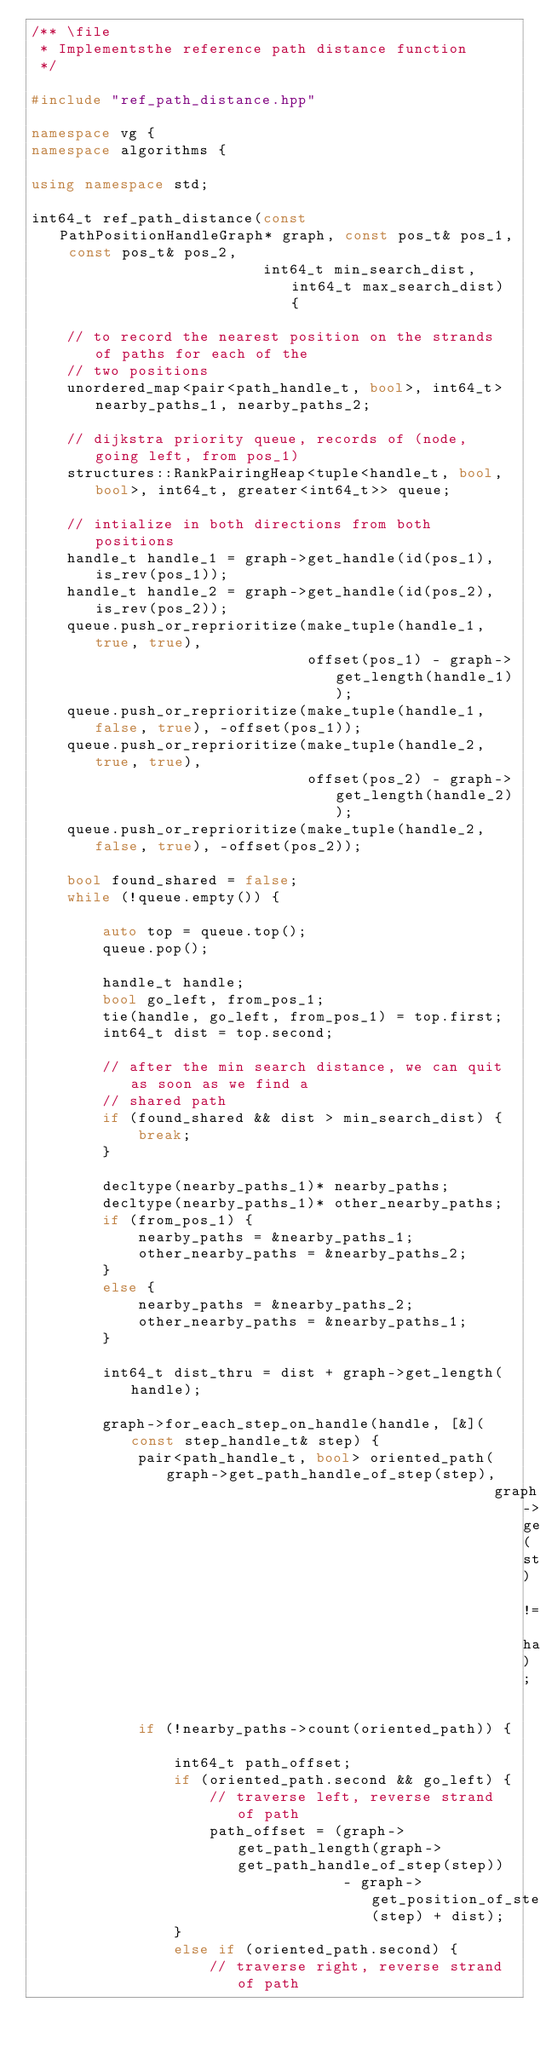Convert code to text. <code><loc_0><loc_0><loc_500><loc_500><_C++_>/** \file
 * Implementsthe reference path distance function
 */

#include "ref_path_distance.hpp"

namespace vg {
namespace algorithms {

using namespace std;

int64_t ref_path_distance(const PathPositionHandleGraph* graph, const pos_t& pos_1, const pos_t& pos_2,
                          int64_t min_search_dist, int64_t max_search_dist) {
    
    // to record the nearest position on the strands of paths for each of the
    // two positions
    unordered_map<pair<path_handle_t, bool>, int64_t> nearby_paths_1, nearby_paths_2;
    
    // dijkstra priority queue, records of (node, going left, from pos_1)
    structures::RankPairingHeap<tuple<handle_t, bool, bool>, int64_t, greater<int64_t>> queue;
    
    // intialize in both directions from both positions
    handle_t handle_1 = graph->get_handle(id(pos_1), is_rev(pos_1));
    handle_t handle_2 = graph->get_handle(id(pos_2), is_rev(pos_2));
    queue.push_or_reprioritize(make_tuple(handle_1, true, true),
                               offset(pos_1) - graph->get_length(handle_1));
    queue.push_or_reprioritize(make_tuple(handle_1, false, true), -offset(pos_1));
    queue.push_or_reprioritize(make_tuple(handle_2, true, true),
                               offset(pos_2) - graph->get_length(handle_2));
    queue.push_or_reprioritize(make_tuple(handle_2, false, true), -offset(pos_2));
    
    bool found_shared = false;
    while (!queue.empty()) {
        
        auto top = queue.top();
        queue.pop();
        
        handle_t handle;
        bool go_left, from_pos_1;
        tie(handle, go_left, from_pos_1) = top.first;
        int64_t dist = top.second;
        
        // after the min search distance, we can quit as soon as we find a
        // shared path
        if (found_shared && dist > min_search_dist) {
            break;
        }
        
        decltype(nearby_paths_1)* nearby_paths;
        decltype(nearby_paths_1)* other_nearby_paths;
        if (from_pos_1) {
            nearby_paths = &nearby_paths_1;
            other_nearby_paths = &nearby_paths_2;
        }
        else {
            nearby_paths = &nearby_paths_2;
            other_nearby_paths = &nearby_paths_1;
        }
        
        int64_t dist_thru = dist + graph->get_length(handle);
        
        graph->for_each_step_on_handle(handle, [&](const step_handle_t& step) {
            pair<path_handle_t, bool> oriented_path(graph->get_path_handle_of_step(step),
                                                    graph->get_handle_of_step(step) != handle);
            
            if (!nearby_paths->count(oriented_path)) {
                
                int64_t path_offset;
                if (oriented_path.second && go_left) {
                    // traverse left, reverse strand of path
                    path_offset = (graph->get_path_length(graph->get_path_handle_of_step(step))
                                   - graph->get_position_of_step(step) + dist);
                }
                else if (oriented_path.second) {
                    // traverse right, reverse strand of path</code> 